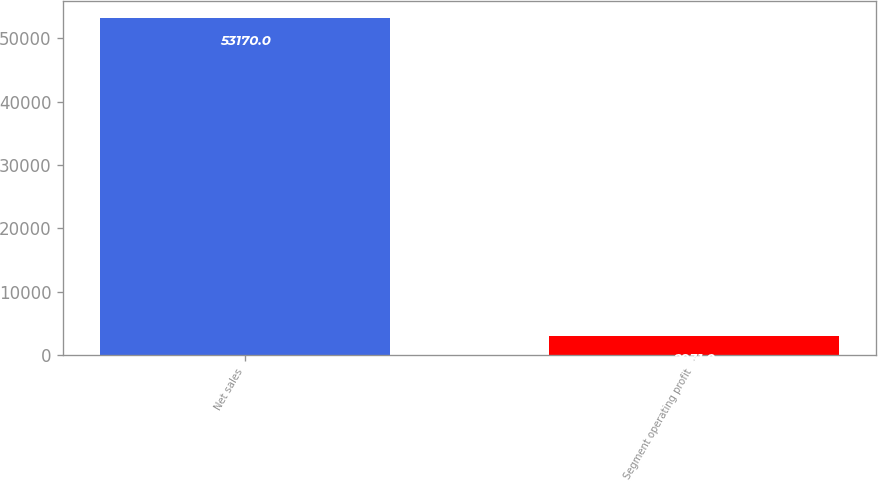Convert chart. <chart><loc_0><loc_0><loc_500><loc_500><bar_chart><fcel>Net sales<fcel>Segment operating profit<nl><fcel>53170<fcel>2931<nl></chart> 